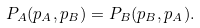<formula> <loc_0><loc_0><loc_500><loc_500>P _ { A } ( p _ { A } , p _ { B } ) = P _ { B } ( p _ { B } , p _ { A } ) .</formula> 